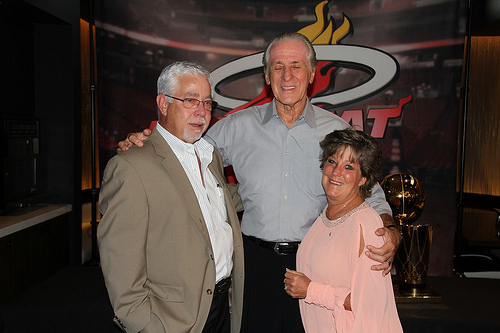<image>
Is there a over coat on the man? No. The over coat is not positioned on the man. They may be near each other, but the over coat is not supported by or resting on top of the man. Is there a man to the left of the woman? Yes. From this viewpoint, the man is positioned to the left side relative to the woman. Is there a man to the right of the woman? No. The man is not to the right of the woman. The horizontal positioning shows a different relationship. 